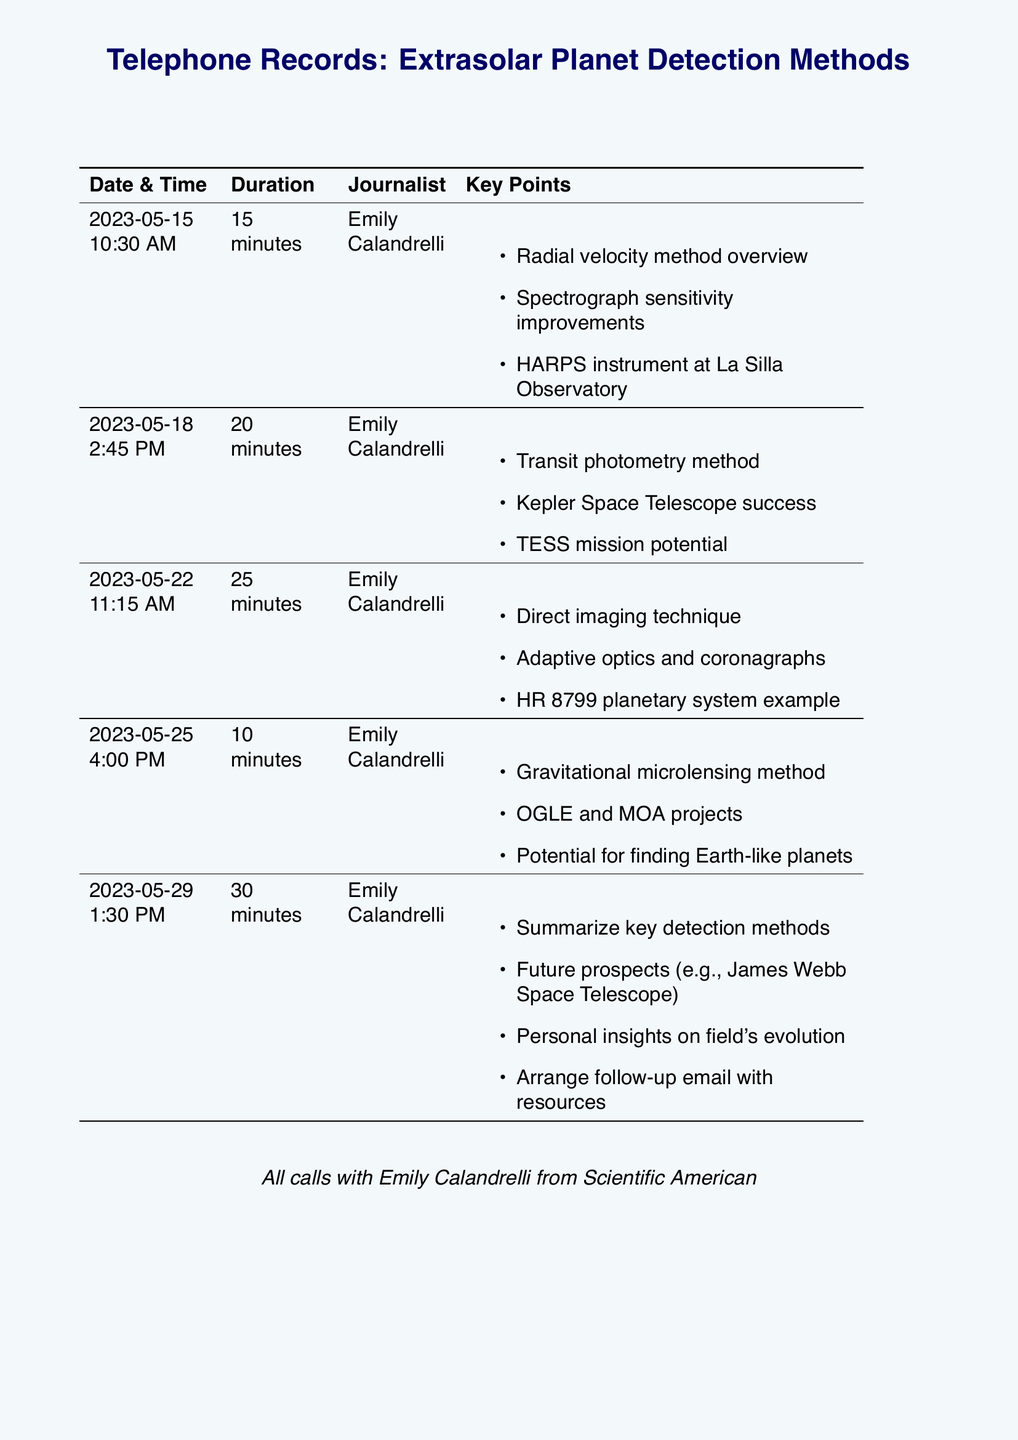What is the name of the journalist in the telephone records? The telephone records indicate that the calls were made with Emily Calandrelli.
Answer: Emily Calandrelli How many minutes was the longest call? The longest call lasted for 30 minutes on May 29, 2023.
Answer: 30 minutes What method was discussed in the call on May 22? The call on May 22 focused on the direct imaging technique.
Answer: Direct imaging technique Which instrument was mentioned in the first call? The HARPS instrument was addressed in the first call on May 15.
Answer: HARPS What was discussed during the call on May 25? The call on May 25 covered the gravitational microlensing method.
Answer: Gravitational microlensing method What is the date of the first call? The first call took place on May 15, 2023.
Answer: May 15, 2023 How many calls were made in total? The records show a total of five calls made to Emily Calandrelli.
Answer: Five What does TESS stand for in the context of extrasolar planet detection? TESS was mentioned in relation to the potential of the mission during the second call.
Answer: TESS Which planetary system example was referenced in the discussion? The HR 8799 planetary system was used as an example in the call on May 22.
Answer: HR 8799 